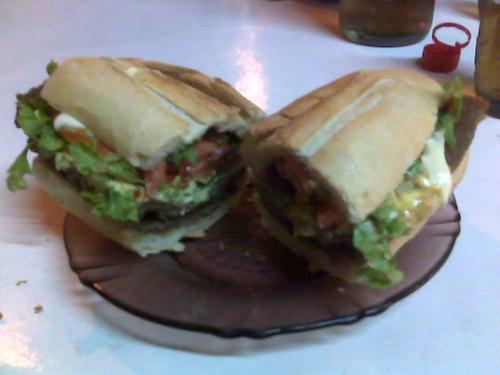How many bottles are visible?
Give a very brief answer. 2. How many sandwiches are there?
Give a very brief answer. 2. How many cats with spots do you see?
Give a very brief answer. 0. 